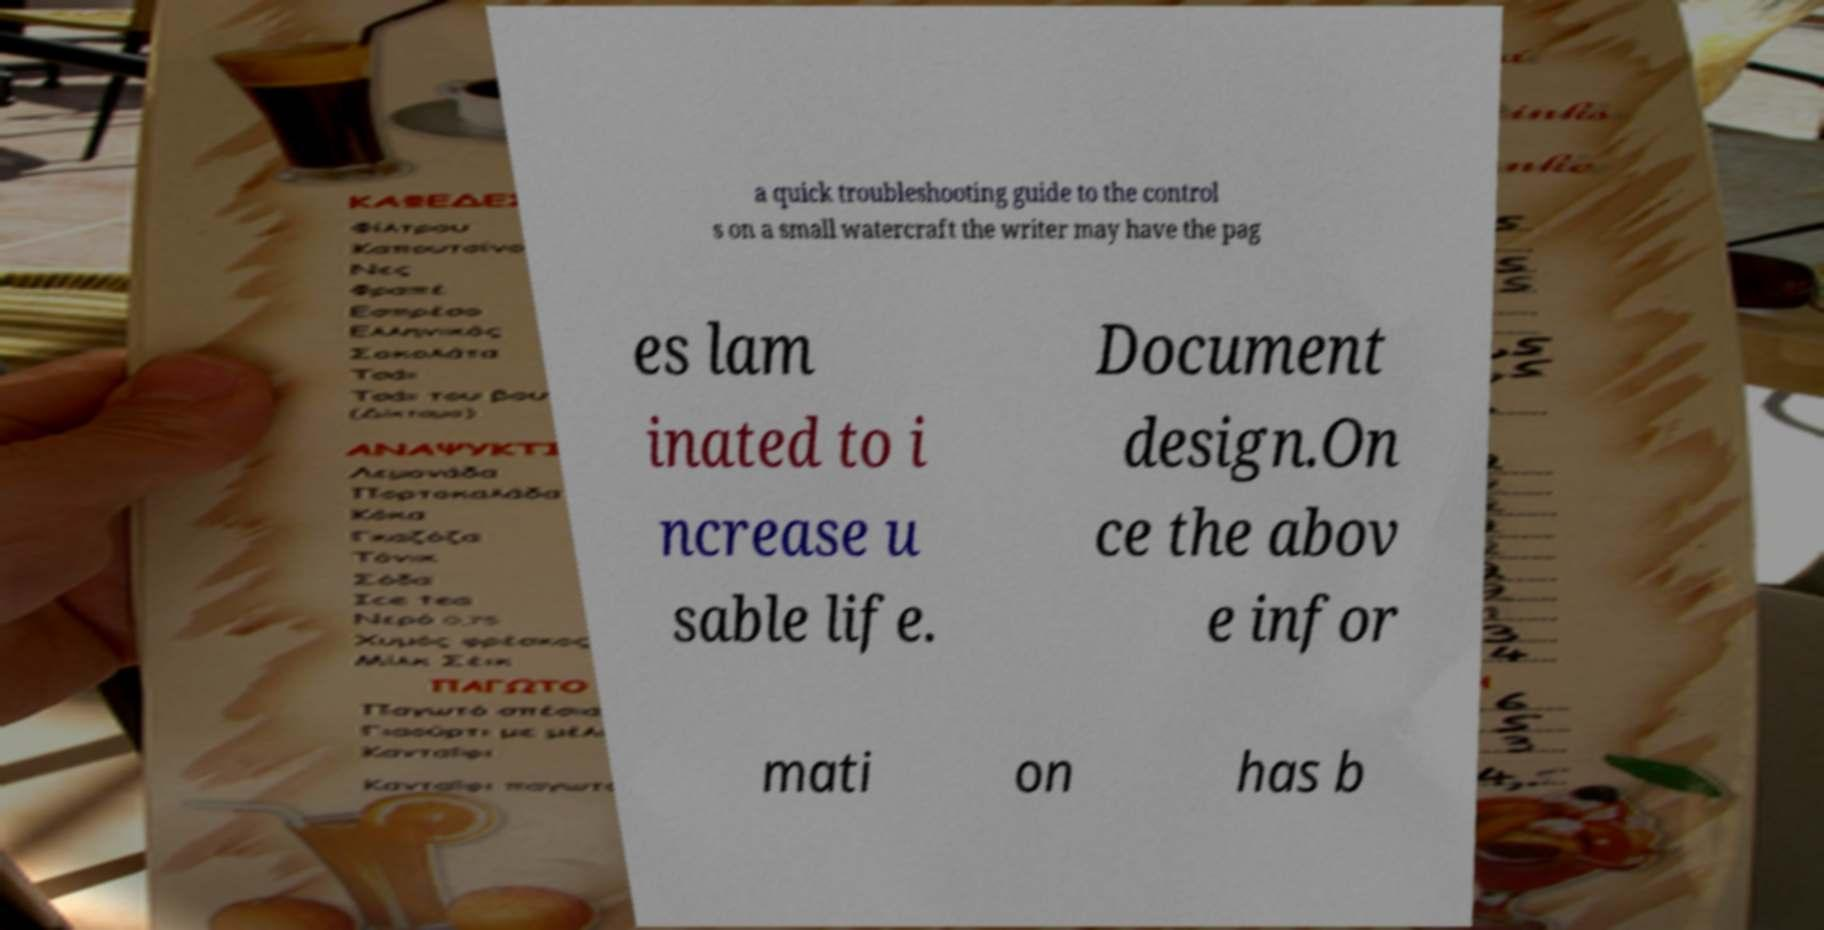Please identify and transcribe the text found in this image. a quick troubleshooting guide to the control s on a small watercraft the writer may have the pag es lam inated to i ncrease u sable life. Document design.On ce the abov e infor mati on has b 